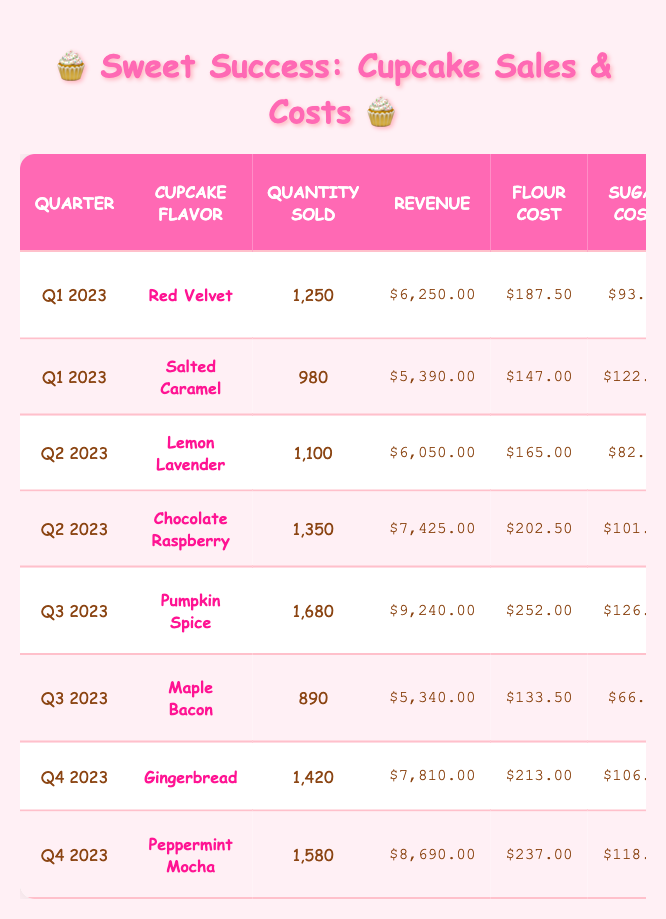What is the total revenue from all cupcake sales in Q2 2023? The revenue from cupcake sales in Q2 2023 can be found by looking at the total for the two flavors listed: Lemon Lavender ($6,050.00) and Chocolate Raspberry ($7,425.00). Adding these together, we get $6,050.00 + $7,425.00 = $13,475.00.
Answer: $13,475.00 Which cupcake flavor sold the highest quantity in Q3 2023? In Q3 2023, the flavors listed are Pumpkin Spice (1,680 sold) and Maple Bacon (890 sold). Comparing the quantities, Pumpkin Spice had a higher quantity sold than Maple Bacon.
Answer: Pumpkin Spice Did the revenue for Peppermint Mocha exceed $8,500.00? The revenue for Peppermint Mocha is $8,690.00. Since this value is greater than $8,500.00, the statement is true.
Answer: Yes What is the average flour cost for cupcakes sold in Q4 2023? The flavors sold in Q4 2023 are Gingerbread ($213.00) and Peppermint Mocha ($237.00). To find the average, we add these two amounts: $213.00 + $237.00 = $450.00. Then, we divide this sum by the number of flavors (2), resulting in $450.00 / 2 = $225.00.
Answer: $225.00 Which quarter had the least quantity sold across all flavors? We need to summarize the quantity sold by quarter: Q1 (1250 + 980 = 2230), Q2 (1100 + 1350 = 2450), Q3 (1680 + 890 = 2570), and Q4 (1420 + 1580 = 3000). The lowest total comes from Q1 with a total of 2,230 cupcakes sold.
Answer: Q1 What was the total cost of special ingredients for the Red Velvet cupcakes? For Red Velvet, the special ingredient costs are Cocoa ($62.50) and Cream Cheese ($312.50). Adding these two together gives us: $62.50 + $312.50 = $375.00.
Answer: $375.00 Is the total quantity sold of the Red Velvet and Salted Caramel cupcakes greater than 2,200? The quantities for Red Velvet and Salted Caramel are 1,250 and 980 respectively. Adding these together gives us: 1,250 + 980 = 2,230, which is indeed greater than 2,200.
Answer: Yes What is the total cost of sugar for all cupcakes sold in Q3 2023? The sugar costs for the flavors in Q3 are Pumpkin Spice ($126.00) and Maple Bacon ($66.75). Adding these costs gives: $126.00 + $66.75 = $192.75.
Answer: $192.75 